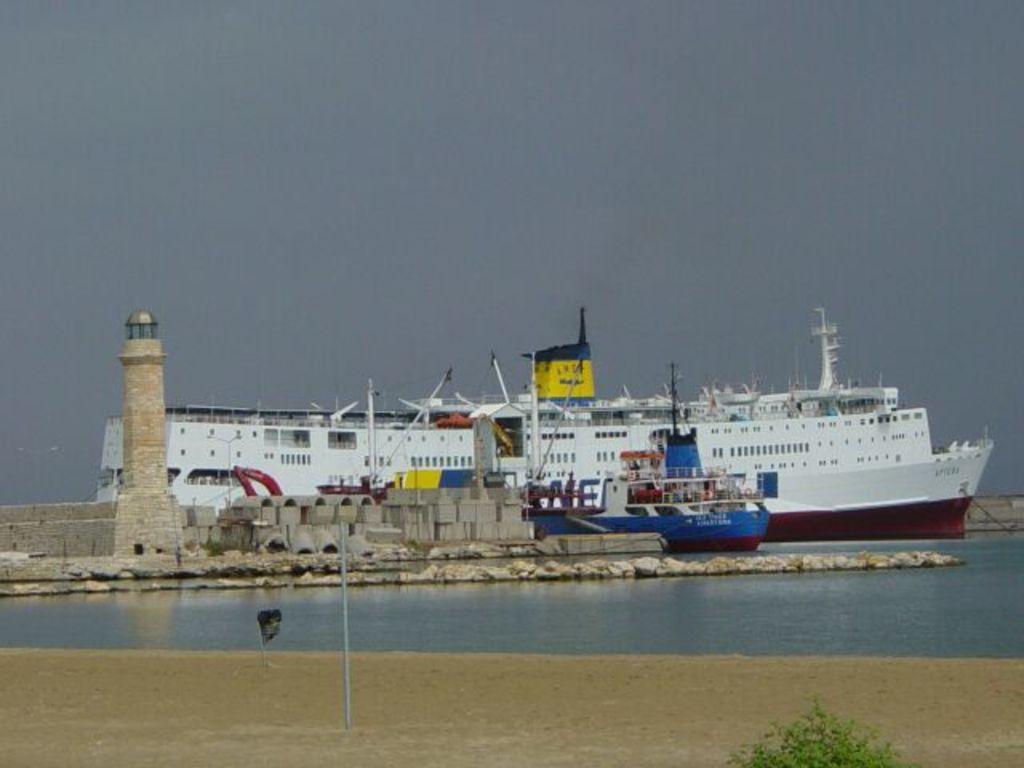How would you summarize this image in a sentence or two? In this picture we can see a ship here, at the bottom there is water, we can see a light house here, there is the sky at the top of the picture, we can see a plant in the front, there is a pole here. 